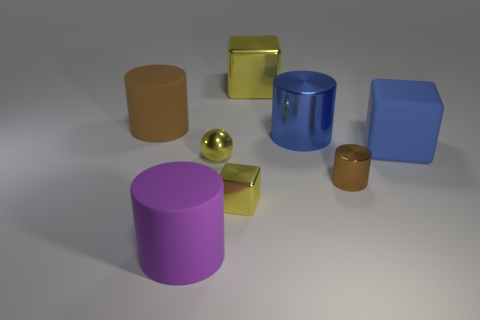Is the big rubber block the same color as the large metallic cylinder?
Make the answer very short. Yes. There is a matte object that is the same color as the tiny cylinder; what is its shape?
Provide a succinct answer. Cylinder. What size is the brown object that is made of the same material as the small ball?
Offer a terse response. Small. Is there any other thing that is the same color as the rubber cube?
Your answer should be very brief. Yes. There is a small object to the left of the tiny cube; what color is it?
Ensure brevity in your answer.  Yellow. There is a big block in front of the yellow metal block behind the small yellow sphere; are there any yellow metallic cubes in front of it?
Provide a short and direct response. Yes. Is the number of large purple matte objects that are to the left of the big purple object greater than the number of green cylinders?
Offer a terse response. No. There is a blue thing that is behind the large blue rubber thing; is it the same shape as the big brown object?
Keep it short and to the point. Yes. Are there any other things that have the same material as the sphere?
Offer a terse response. Yes. What number of things are either tiny yellow spheres or cylinders behind the tiny brown cylinder?
Provide a short and direct response. 3. 